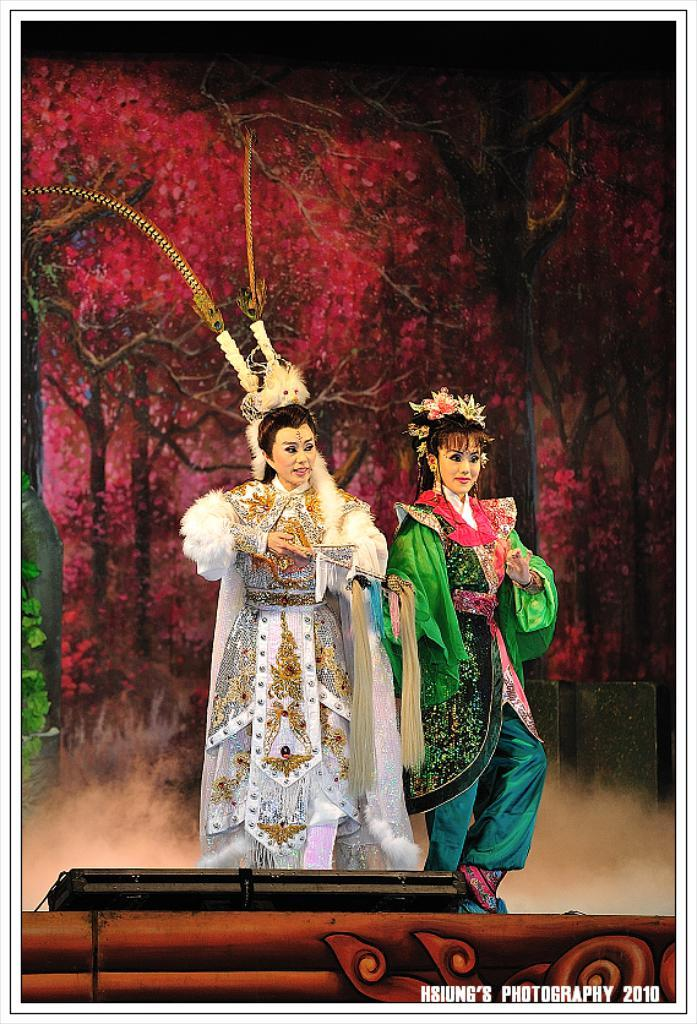How many ladies are in the image? There are two ladies in the image. What can be observed about the ladies' costumes? The ladies are wearing different costumes. Can you describe the color of the costumes? One lady is wearing a white costume, and the other lady is wearing a green costume. What is visible in the background of the image? There are trees visible in the background of the image. What is a characteristic of the trees? The trees have leaves. What type of cake is being prepared by the ladies in the image? There is no cake present in the image, nor are the ladies preparing one. 